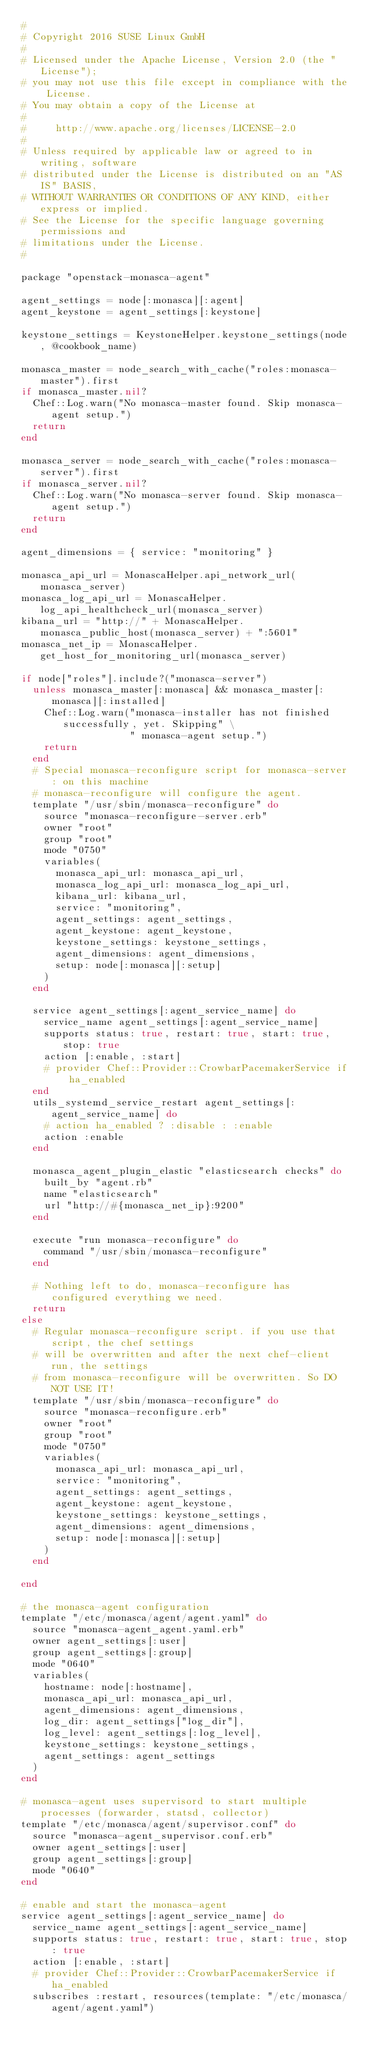<code> <loc_0><loc_0><loc_500><loc_500><_Ruby_>#
# Copyright 2016 SUSE Linux GmbH
#
# Licensed under the Apache License, Version 2.0 (the "License");
# you may not use this file except in compliance with the License.
# You may obtain a copy of the License at
#
#     http://www.apache.org/licenses/LICENSE-2.0
#
# Unless required by applicable law or agreed to in writing, software
# distributed under the License is distributed on an "AS IS" BASIS,
# WITHOUT WARRANTIES OR CONDITIONS OF ANY KIND, either express or implied.
# See the License for the specific language governing permissions and
# limitations under the License.
#

package "openstack-monasca-agent"

agent_settings = node[:monasca][:agent]
agent_keystone = agent_settings[:keystone]

keystone_settings = KeystoneHelper.keystone_settings(node, @cookbook_name)

monasca_master = node_search_with_cache("roles:monasca-master").first
if monasca_master.nil?
  Chef::Log.warn("No monasca-master found. Skip monasca-agent setup.")
  return
end

monasca_server = node_search_with_cache("roles:monasca-server").first
if monasca_server.nil?
  Chef::Log.warn("No monasca-server found. Skip monasca-agent setup.")
  return
end

agent_dimensions = { service: "monitoring" }

monasca_api_url = MonascaHelper.api_network_url(monasca_server)
monasca_log_api_url = MonascaHelper.log_api_healthcheck_url(monasca_server)
kibana_url = "http://" + MonascaHelper.monasca_public_host(monasca_server) + ":5601"
monasca_net_ip = MonascaHelper.get_host_for_monitoring_url(monasca_server)

if node["roles"].include?("monasca-server")
  unless monasca_master[:monasca] && monasca_master[:monasca][:installed]
    Chef::Log.warn("monasca-installer has not finished successfully, yet. Skipping" \
                   " monasca-agent setup.")
    return
  end
  # Special monasca-reconfigure script for monasca-server: on this machine
  # monasca-reconfigure will configure the agent.
  template "/usr/sbin/monasca-reconfigure" do
    source "monasca-reconfigure-server.erb"
    owner "root"
    group "root"
    mode "0750"
    variables(
      monasca_api_url: monasca_api_url,
      monasca_log_api_url: monasca_log_api_url,
      kibana_url: kibana_url,
      service: "monitoring",
      agent_settings: agent_settings,
      agent_keystone: agent_keystone,
      keystone_settings: keystone_settings,
      agent_dimensions: agent_dimensions,
      setup: node[:monasca][:setup]
    )
  end

  service agent_settings[:agent_service_name] do
    service_name agent_settings[:agent_service_name]
    supports status: true, restart: true, start: true, stop: true
    action [:enable, :start]
    # provider Chef::Provider::CrowbarPacemakerService if ha_enabled
  end
  utils_systemd_service_restart agent_settings[:agent_service_name] do
    # action ha_enabled ? :disable : :enable
    action :enable
  end

  monasca_agent_plugin_elastic "elasticsearch checks" do
    built_by "agent.rb"
    name "elasticsearch"
    url "http://#{monasca_net_ip}:9200"
  end

  execute "run monasca-reconfigure" do
    command "/usr/sbin/monasca-reconfigure"
  end

  # Nothing left to do, monasca-reconfigure has configured everything we need.
  return
else
  # Regular monasca-reconfigure script. if you use that script, the chef settings
  # will be overwritten and after the next chef-client run, the settings
  # from monasca-reconfigure will be overwritten. So DO NOT USE IT!
  template "/usr/sbin/monasca-reconfigure" do
    source "monasca-reconfigure.erb"
    owner "root"
    group "root"
    mode "0750"
    variables(
      monasca_api_url: monasca_api_url,
      service: "monitoring",
      agent_settings: agent_settings,
      agent_keystone: agent_keystone,
      keystone_settings: keystone_settings,
      agent_dimensions: agent_dimensions,
      setup: node[:monasca][:setup]
    )
  end

end

# the monasca-agent configuration
template "/etc/monasca/agent/agent.yaml" do
  source "monasca-agent_agent.yaml.erb"
  owner agent_settings[:user]
  group agent_settings[:group]
  mode "0640"
  variables(
    hostname: node[:hostname],
    monasca_api_url: monasca_api_url,
    agent_dimensions: agent_dimensions,
    log_dir: agent_settings["log_dir"],
    log_level: agent_settings[:log_level],
    keystone_settings: keystone_settings,
    agent_settings: agent_settings
  )
end

# monasca-agent uses supervisord to start multiple processes (forwarder, statsd, collector)
template "/etc/monasca/agent/supervisor.conf" do
  source "monasca-agent_supervisor.conf.erb"
  owner agent_settings[:user]
  group agent_settings[:group]
  mode "0640"
end

# enable and start the monasca-agent
service agent_settings[:agent_service_name] do
  service_name agent_settings[:agent_service_name]
  supports status: true, restart: true, start: true, stop: true
  action [:enable, :start]
  # provider Chef::Provider::CrowbarPacemakerService if ha_enabled
  subscribes :restart, resources(template: "/etc/monasca/agent/agent.yaml")</code> 